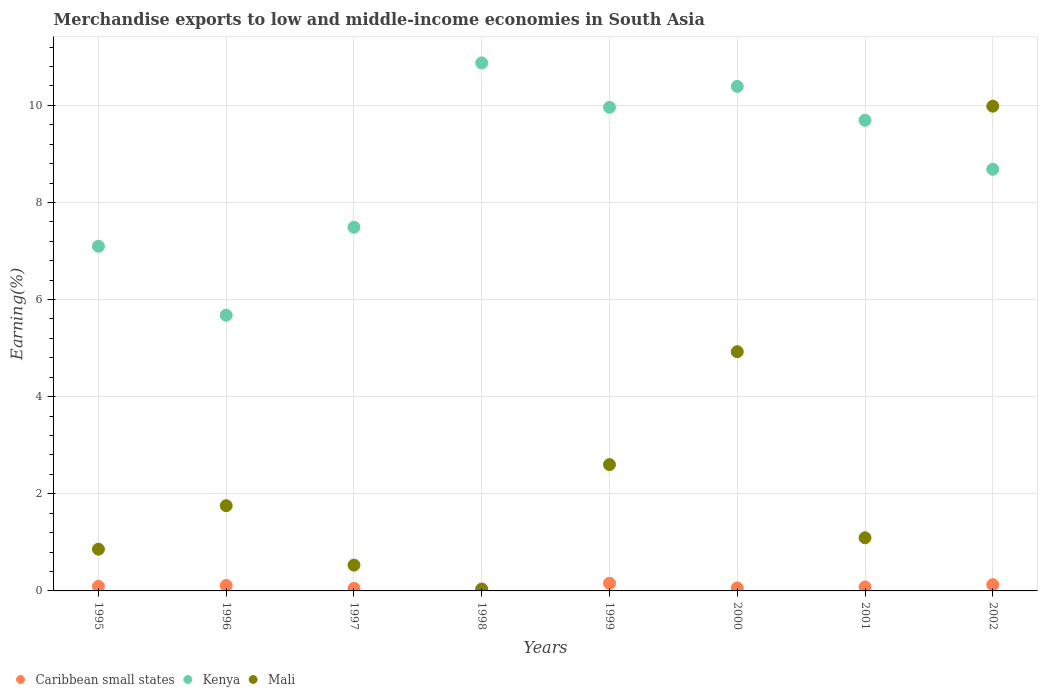How many different coloured dotlines are there?
Give a very brief answer. 3. What is the percentage of amount earned from merchandise exports in Mali in 2002?
Provide a succinct answer. 9.98. Across all years, what is the maximum percentage of amount earned from merchandise exports in Caribbean small states?
Your answer should be very brief. 0.16. Across all years, what is the minimum percentage of amount earned from merchandise exports in Kenya?
Your answer should be very brief. 5.68. In which year was the percentage of amount earned from merchandise exports in Mali minimum?
Provide a short and direct response. 1998. What is the total percentage of amount earned from merchandise exports in Mali in the graph?
Provide a succinct answer. 21.78. What is the difference between the percentage of amount earned from merchandise exports in Mali in 1996 and that in 1998?
Provide a short and direct response. 1.72. What is the difference between the percentage of amount earned from merchandise exports in Caribbean small states in 2002 and the percentage of amount earned from merchandise exports in Mali in 2001?
Offer a terse response. -0.97. What is the average percentage of amount earned from merchandise exports in Caribbean small states per year?
Ensure brevity in your answer.  0.09. In the year 1999, what is the difference between the percentage of amount earned from merchandise exports in Mali and percentage of amount earned from merchandise exports in Kenya?
Your answer should be compact. -7.36. In how many years, is the percentage of amount earned from merchandise exports in Kenya greater than 3.6 %?
Offer a terse response. 8. What is the ratio of the percentage of amount earned from merchandise exports in Mali in 2000 to that in 2001?
Your answer should be compact. 4.5. What is the difference between the highest and the second highest percentage of amount earned from merchandise exports in Kenya?
Your answer should be compact. 0.48. What is the difference between the highest and the lowest percentage of amount earned from merchandise exports in Kenya?
Ensure brevity in your answer.  5.2. How many dotlines are there?
Your answer should be compact. 3. How many years are there in the graph?
Make the answer very short. 8. Does the graph contain any zero values?
Offer a very short reply. No. Where does the legend appear in the graph?
Make the answer very short. Bottom left. How many legend labels are there?
Provide a succinct answer. 3. What is the title of the graph?
Offer a very short reply. Merchandise exports to low and middle-income economies in South Asia. What is the label or title of the Y-axis?
Provide a short and direct response. Earning(%). What is the Earning(%) in Caribbean small states in 1995?
Give a very brief answer. 0.09. What is the Earning(%) of Kenya in 1995?
Provide a short and direct response. 7.1. What is the Earning(%) of Mali in 1995?
Make the answer very short. 0.86. What is the Earning(%) of Caribbean small states in 1996?
Provide a short and direct response. 0.11. What is the Earning(%) in Kenya in 1996?
Make the answer very short. 5.68. What is the Earning(%) of Mali in 1996?
Your answer should be compact. 1.76. What is the Earning(%) in Caribbean small states in 1997?
Offer a very short reply. 0.05. What is the Earning(%) of Kenya in 1997?
Give a very brief answer. 7.49. What is the Earning(%) of Mali in 1997?
Provide a succinct answer. 0.53. What is the Earning(%) of Caribbean small states in 1998?
Your answer should be very brief. 0.04. What is the Earning(%) in Kenya in 1998?
Keep it short and to the point. 10.87. What is the Earning(%) in Mali in 1998?
Make the answer very short. 0.03. What is the Earning(%) of Caribbean small states in 1999?
Make the answer very short. 0.16. What is the Earning(%) in Kenya in 1999?
Your answer should be very brief. 9.96. What is the Earning(%) of Mali in 1999?
Provide a succinct answer. 2.6. What is the Earning(%) of Caribbean small states in 2000?
Offer a very short reply. 0.06. What is the Earning(%) in Kenya in 2000?
Your response must be concise. 10.39. What is the Earning(%) of Mali in 2000?
Provide a short and direct response. 4.93. What is the Earning(%) in Caribbean small states in 2001?
Keep it short and to the point. 0.08. What is the Earning(%) of Kenya in 2001?
Offer a very short reply. 9.69. What is the Earning(%) of Mali in 2001?
Your answer should be very brief. 1.09. What is the Earning(%) of Caribbean small states in 2002?
Make the answer very short. 0.13. What is the Earning(%) in Kenya in 2002?
Offer a terse response. 8.68. What is the Earning(%) of Mali in 2002?
Make the answer very short. 9.98. Across all years, what is the maximum Earning(%) in Caribbean small states?
Provide a short and direct response. 0.16. Across all years, what is the maximum Earning(%) in Kenya?
Ensure brevity in your answer.  10.87. Across all years, what is the maximum Earning(%) of Mali?
Provide a succinct answer. 9.98. Across all years, what is the minimum Earning(%) in Caribbean small states?
Your answer should be very brief. 0.04. Across all years, what is the minimum Earning(%) in Kenya?
Ensure brevity in your answer.  5.68. Across all years, what is the minimum Earning(%) of Mali?
Provide a short and direct response. 0.03. What is the total Earning(%) of Caribbean small states in the graph?
Provide a succinct answer. 0.73. What is the total Earning(%) of Kenya in the graph?
Ensure brevity in your answer.  69.86. What is the total Earning(%) in Mali in the graph?
Offer a terse response. 21.78. What is the difference between the Earning(%) of Caribbean small states in 1995 and that in 1996?
Offer a terse response. -0.02. What is the difference between the Earning(%) of Kenya in 1995 and that in 1996?
Make the answer very short. 1.42. What is the difference between the Earning(%) in Mali in 1995 and that in 1996?
Ensure brevity in your answer.  -0.9. What is the difference between the Earning(%) of Caribbean small states in 1995 and that in 1997?
Your answer should be compact. 0.04. What is the difference between the Earning(%) in Kenya in 1995 and that in 1997?
Offer a very short reply. -0.39. What is the difference between the Earning(%) of Mali in 1995 and that in 1997?
Keep it short and to the point. 0.33. What is the difference between the Earning(%) of Caribbean small states in 1995 and that in 1998?
Keep it short and to the point. 0.05. What is the difference between the Earning(%) of Kenya in 1995 and that in 1998?
Your answer should be compact. -3.78. What is the difference between the Earning(%) in Mali in 1995 and that in 1998?
Your response must be concise. 0.83. What is the difference between the Earning(%) in Caribbean small states in 1995 and that in 1999?
Offer a very short reply. -0.06. What is the difference between the Earning(%) of Kenya in 1995 and that in 1999?
Your answer should be very brief. -2.86. What is the difference between the Earning(%) in Mali in 1995 and that in 1999?
Your response must be concise. -1.74. What is the difference between the Earning(%) in Caribbean small states in 1995 and that in 2000?
Your answer should be compact. 0.03. What is the difference between the Earning(%) of Kenya in 1995 and that in 2000?
Provide a succinct answer. -3.29. What is the difference between the Earning(%) in Mali in 1995 and that in 2000?
Ensure brevity in your answer.  -4.07. What is the difference between the Earning(%) of Caribbean small states in 1995 and that in 2001?
Keep it short and to the point. 0.01. What is the difference between the Earning(%) of Kenya in 1995 and that in 2001?
Your answer should be compact. -2.59. What is the difference between the Earning(%) in Mali in 1995 and that in 2001?
Your answer should be very brief. -0.23. What is the difference between the Earning(%) of Caribbean small states in 1995 and that in 2002?
Offer a very short reply. -0.03. What is the difference between the Earning(%) of Kenya in 1995 and that in 2002?
Your answer should be very brief. -1.58. What is the difference between the Earning(%) in Mali in 1995 and that in 2002?
Make the answer very short. -9.12. What is the difference between the Earning(%) in Caribbean small states in 1996 and that in 1997?
Your response must be concise. 0.06. What is the difference between the Earning(%) of Kenya in 1996 and that in 1997?
Your response must be concise. -1.81. What is the difference between the Earning(%) of Mali in 1996 and that in 1997?
Your answer should be very brief. 1.22. What is the difference between the Earning(%) of Caribbean small states in 1996 and that in 1998?
Ensure brevity in your answer.  0.07. What is the difference between the Earning(%) in Kenya in 1996 and that in 1998?
Ensure brevity in your answer.  -5.2. What is the difference between the Earning(%) of Mali in 1996 and that in 1998?
Provide a succinct answer. 1.72. What is the difference between the Earning(%) in Caribbean small states in 1996 and that in 1999?
Offer a terse response. -0.05. What is the difference between the Earning(%) in Kenya in 1996 and that in 1999?
Give a very brief answer. -4.28. What is the difference between the Earning(%) of Mali in 1996 and that in 1999?
Give a very brief answer. -0.85. What is the difference between the Earning(%) of Caribbean small states in 1996 and that in 2000?
Your response must be concise. 0.05. What is the difference between the Earning(%) in Kenya in 1996 and that in 2000?
Make the answer very short. -4.71. What is the difference between the Earning(%) in Mali in 1996 and that in 2000?
Provide a short and direct response. -3.17. What is the difference between the Earning(%) in Kenya in 1996 and that in 2001?
Provide a short and direct response. -4.01. What is the difference between the Earning(%) in Mali in 1996 and that in 2001?
Your response must be concise. 0.66. What is the difference between the Earning(%) in Caribbean small states in 1996 and that in 2002?
Offer a terse response. -0.02. What is the difference between the Earning(%) of Kenya in 1996 and that in 2002?
Provide a short and direct response. -3. What is the difference between the Earning(%) of Mali in 1996 and that in 2002?
Keep it short and to the point. -8.23. What is the difference between the Earning(%) in Caribbean small states in 1997 and that in 1998?
Provide a short and direct response. 0.01. What is the difference between the Earning(%) in Kenya in 1997 and that in 1998?
Provide a succinct answer. -3.38. What is the difference between the Earning(%) in Mali in 1997 and that in 1998?
Your response must be concise. 0.5. What is the difference between the Earning(%) in Caribbean small states in 1997 and that in 1999?
Provide a succinct answer. -0.1. What is the difference between the Earning(%) in Kenya in 1997 and that in 1999?
Your response must be concise. -2.47. What is the difference between the Earning(%) in Mali in 1997 and that in 1999?
Provide a short and direct response. -2.07. What is the difference between the Earning(%) in Caribbean small states in 1997 and that in 2000?
Your answer should be compact. -0.01. What is the difference between the Earning(%) of Kenya in 1997 and that in 2000?
Your answer should be compact. -2.9. What is the difference between the Earning(%) of Mali in 1997 and that in 2000?
Your answer should be compact. -4.39. What is the difference between the Earning(%) of Caribbean small states in 1997 and that in 2001?
Offer a very short reply. -0.03. What is the difference between the Earning(%) of Kenya in 1997 and that in 2001?
Your answer should be very brief. -2.2. What is the difference between the Earning(%) of Mali in 1997 and that in 2001?
Your answer should be very brief. -0.56. What is the difference between the Earning(%) in Caribbean small states in 1997 and that in 2002?
Your answer should be compact. -0.08. What is the difference between the Earning(%) of Kenya in 1997 and that in 2002?
Your answer should be compact. -1.19. What is the difference between the Earning(%) in Mali in 1997 and that in 2002?
Keep it short and to the point. -9.45. What is the difference between the Earning(%) in Caribbean small states in 1998 and that in 1999?
Ensure brevity in your answer.  -0.12. What is the difference between the Earning(%) of Kenya in 1998 and that in 1999?
Provide a short and direct response. 0.91. What is the difference between the Earning(%) of Mali in 1998 and that in 1999?
Your response must be concise. -2.57. What is the difference between the Earning(%) in Caribbean small states in 1998 and that in 2000?
Ensure brevity in your answer.  -0.02. What is the difference between the Earning(%) of Kenya in 1998 and that in 2000?
Your answer should be compact. 0.48. What is the difference between the Earning(%) in Mali in 1998 and that in 2000?
Offer a terse response. -4.89. What is the difference between the Earning(%) of Caribbean small states in 1998 and that in 2001?
Provide a succinct answer. -0.04. What is the difference between the Earning(%) in Kenya in 1998 and that in 2001?
Give a very brief answer. 1.18. What is the difference between the Earning(%) of Mali in 1998 and that in 2001?
Provide a succinct answer. -1.06. What is the difference between the Earning(%) in Caribbean small states in 1998 and that in 2002?
Offer a very short reply. -0.09. What is the difference between the Earning(%) in Kenya in 1998 and that in 2002?
Your answer should be very brief. 2.19. What is the difference between the Earning(%) in Mali in 1998 and that in 2002?
Provide a succinct answer. -9.95. What is the difference between the Earning(%) in Caribbean small states in 1999 and that in 2000?
Give a very brief answer. 0.09. What is the difference between the Earning(%) in Kenya in 1999 and that in 2000?
Give a very brief answer. -0.43. What is the difference between the Earning(%) in Mali in 1999 and that in 2000?
Keep it short and to the point. -2.32. What is the difference between the Earning(%) of Caribbean small states in 1999 and that in 2001?
Provide a succinct answer. 0.08. What is the difference between the Earning(%) in Kenya in 1999 and that in 2001?
Offer a very short reply. 0.27. What is the difference between the Earning(%) of Mali in 1999 and that in 2001?
Offer a very short reply. 1.51. What is the difference between the Earning(%) of Caribbean small states in 1999 and that in 2002?
Provide a short and direct response. 0.03. What is the difference between the Earning(%) in Kenya in 1999 and that in 2002?
Your answer should be compact. 1.28. What is the difference between the Earning(%) in Mali in 1999 and that in 2002?
Offer a terse response. -7.38. What is the difference between the Earning(%) of Caribbean small states in 2000 and that in 2001?
Offer a terse response. -0.02. What is the difference between the Earning(%) of Kenya in 2000 and that in 2001?
Your answer should be compact. 0.7. What is the difference between the Earning(%) in Mali in 2000 and that in 2001?
Make the answer very short. 3.83. What is the difference between the Earning(%) of Caribbean small states in 2000 and that in 2002?
Your response must be concise. -0.07. What is the difference between the Earning(%) in Kenya in 2000 and that in 2002?
Keep it short and to the point. 1.71. What is the difference between the Earning(%) of Mali in 2000 and that in 2002?
Your answer should be compact. -5.06. What is the difference between the Earning(%) of Caribbean small states in 2001 and that in 2002?
Make the answer very short. -0.05. What is the difference between the Earning(%) in Kenya in 2001 and that in 2002?
Keep it short and to the point. 1.01. What is the difference between the Earning(%) in Mali in 2001 and that in 2002?
Your response must be concise. -8.89. What is the difference between the Earning(%) in Caribbean small states in 1995 and the Earning(%) in Kenya in 1996?
Your response must be concise. -5.58. What is the difference between the Earning(%) of Caribbean small states in 1995 and the Earning(%) of Mali in 1996?
Ensure brevity in your answer.  -1.66. What is the difference between the Earning(%) of Kenya in 1995 and the Earning(%) of Mali in 1996?
Your answer should be very brief. 5.34. What is the difference between the Earning(%) in Caribbean small states in 1995 and the Earning(%) in Kenya in 1997?
Provide a succinct answer. -7.39. What is the difference between the Earning(%) of Caribbean small states in 1995 and the Earning(%) of Mali in 1997?
Ensure brevity in your answer.  -0.44. What is the difference between the Earning(%) in Kenya in 1995 and the Earning(%) in Mali in 1997?
Your answer should be compact. 6.57. What is the difference between the Earning(%) of Caribbean small states in 1995 and the Earning(%) of Kenya in 1998?
Keep it short and to the point. -10.78. What is the difference between the Earning(%) of Caribbean small states in 1995 and the Earning(%) of Mali in 1998?
Your response must be concise. 0.06. What is the difference between the Earning(%) in Kenya in 1995 and the Earning(%) in Mali in 1998?
Make the answer very short. 7.07. What is the difference between the Earning(%) in Caribbean small states in 1995 and the Earning(%) in Kenya in 1999?
Provide a short and direct response. -9.86. What is the difference between the Earning(%) of Caribbean small states in 1995 and the Earning(%) of Mali in 1999?
Your answer should be very brief. -2.51. What is the difference between the Earning(%) of Kenya in 1995 and the Earning(%) of Mali in 1999?
Offer a terse response. 4.5. What is the difference between the Earning(%) in Caribbean small states in 1995 and the Earning(%) in Kenya in 2000?
Give a very brief answer. -10.3. What is the difference between the Earning(%) in Caribbean small states in 1995 and the Earning(%) in Mali in 2000?
Your answer should be compact. -4.83. What is the difference between the Earning(%) of Kenya in 1995 and the Earning(%) of Mali in 2000?
Make the answer very short. 2.17. What is the difference between the Earning(%) of Caribbean small states in 1995 and the Earning(%) of Kenya in 2001?
Your answer should be compact. -9.6. What is the difference between the Earning(%) in Caribbean small states in 1995 and the Earning(%) in Mali in 2001?
Provide a short and direct response. -1. What is the difference between the Earning(%) of Kenya in 1995 and the Earning(%) of Mali in 2001?
Provide a short and direct response. 6. What is the difference between the Earning(%) of Caribbean small states in 1995 and the Earning(%) of Kenya in 2002?
Keep it short and to the point. -8.59. What is the difference between the Earning(%) of Caribbean small states in 1995 and the Earning(%) of Mali in 2002?
Your response must be concise. -9.89. What is the difference between the Earning(%) of Kenya in 1995 and the Earning(%) of Mali in 2002?
Keep it short and to the point. -2.88. What is the difference between the Earning(%) of Caribbean small states in 1996 and the Earning(%) of Kenya in 1997?
Give a very brief answer. -7.38. What is the difference between the Earning(%) in Caribbean small states in 1996 and the Earning(%) in Mali in 1997?
Provide a succinct answer. -0.42. What is the difference between the Earning(%) in Kenya in 1996 and the Earning(%) in Mali in 1997?
Keep it short and to the point. 5.15. What is the difference between the Earning(%) of Caribbean small states in 1996 and the Earning(%) of Kenya in 1998?
Make the answer very short. -10.76. What is the difference between the Earning(%) of Caribbean small states in 1996 and the Earning(%) of Mali in 1998?
Give a very brief answer. 0.08. What is the difference between the Earning(%) of Kenya in 1996 and the Earning(%) of Mali in 1998?
Keep it short and to the point. 5.65. What is the difference between the Earning(%) of Caribbean small states in 1996 and the Earning(%) of Kenya in 1999?
Provide a succinct answer. -9.85. What is the difference between the Earning(%) in Caribbean small states in 1996 and the Earning(%) in Mali in 1999?
Provide a succinct answer. -2.49. What is the difference between the Earning(%) in Kenya in 1996 and the Earning(%) in Mali in 1999?
Your response must be concise. 3.08. What is the difference between the Earning(%) of Caribbean small states in 1996 and the Earning(%) of Kenya in 2000?
Offer a very short reply. -10.28. What is the difference between the Earning(%) of Caribbean small states in 1996 and the Earning(%) of Mali in 2000?
Offer a terse response. -4.81. What is the difference between the Earning(%) in Kenya in 1996 and the Earning(%) in Mali in 2000?
Your answer should be very brief. 0.75. What is the difference between the Earning(%) of Caribbean small states in 1996 and the Earning(%) of Kenya in 2001?
Offer a terse response. -9.58. What is the difference between the Earning(%) of Caribbean small states in 1996 and the Earning(%) of Mali in 2001?
Provide a succinct answer. -0.98. What is the difference between the Earning(%) in Kenya in 1996 and the Earning(%) in Mali in 2001?
Provide a short and direct response. 4.58. What is the difference between the Earning(%) of Caribbean small states in 1996 and the Earning(%) of Kenya in 2002?
Your response must be concise. -8.57. What is the difference between the Earning(%) of Caribbean small states in 1996 and the Earning(%) of Mali in 2002?
Make the answer very short. -9.87. What is the difference between the Earning(%) in Kenya in 1996 and the Earning(%) in Mali in 2002?
Offer a terse response. -4.3. What is the difference between the Earning(%) of Caribbean small states in 1997 and the Earning(%) of Kenya in 1998?
Your response must be concise. -10.82. What is the difference between the Earning(%) of Caribbean small states in 1997 and the Earning(%) of Mali in 1998?
Give a very brief answer. 0.02. What is the difference between the Earning(%) in Kenya in 1997 and the Earning(%) in Mali in 1998?
Your answer should be very brief. 7.46. What is the difference between the Earning(%) in Caribbean small states in 1997 and the Earning(%) in Kenya in 1999?
Offer a terse response. -9.91. What is the difference between the Earning(%) of Caribbean small states in 1997 and the Earning(%) of Mali in 1999?
Your answer should be very brief. -2.55. What is the difference between the Earning(%) of Kenya in 1997 and the Earning(%) of Mali in 1999?
Make the answer very short. 4.89. What is the difference between the Earning(%) in Caribbean small states in 1997 and the Earning(%) in Kenya in 2000?
Offer a very short reply. -10.34. What is the difference between the Earning(%) in Caribbean small states in 1997 and the Earning(%) in Mali in 2000?
Your answer should be compact. -4.87. What is the difference between the Earning(%) of Kenya in 1997 and the Earning(%) of Mali in 2000?
Ensure brevity in your answer.  2.56. What is the difference between the Earning(%) in Caribbean small states in 1997 and the Earning(%) in Kenya in 2001?
Your answer should be very brief. -9.64. What is the difference between the Earning(%) in Caribbean small states in 1997 and the Earning(%) in Mali in 2001?
Your answer should be very brief. -1.04. What is the difference between the Earning(%) in Kenya in 1997 and the Earning(%) in Mali in 2001?
Give a very brief answer. 6.4. What is the difference between the Earning(%) in Caribbean small states in 1997 and the Earning(%) in Kenya in 2002?
Make the answer very short. -8.63. What is the difference between the Earning(%) in Caribbean small states in 1997 and the Earning(%) in Mali in 2002?
Make the answer very short. -9.93. What is the difference between the Earning(%) of Kenya in 1997 and the Earning(%) of Mali in 2002?
Keep it short and to the point. -2.49. What is the difference between the Earning(%) of Caribbean small states in 1998 and the Earning(%) of Kenya in 1999?
Keep it short and to the point. -9.92. What is the difference between the Earning(%) in Caribbean small states in 1998 and the Earning(%) in Mali in 1999?
Your answer should be very brief. -2.56. What is the difference between the Earning(%) in Kenya in 1998 and the Earning(%) in Mali in 1999?
Provide a short and direct response. 8.27. What is the difference between the Earning(%) in Caribbean small states in 1998 and the Earning(%) in Kenya in 2000?
Make the answer very short. -10.35. What is the difference between the Earning(%) of Caribbean small states in 1998 and the Earning(%) of Mali in 2000?
Offer a very short reply. -4.88. What is the difference between the Earning(%) of Kenya in 1998 and the Earning(%) of Mali in 2000?
Offer a terse response. 5.95. What is the difference between the Earning(%) in Caribbean small states in 1998 and the Earning(%) in Kenya in 2001?
Offer a terse response. -9.65. What is the difference between the Earning(%) in Caribbean small states in 1998 and the Earning(%) in Mali in 2001?
Offer a very short reply. -1.05. What is the difference between the Earning(%) of Kenya in 1998 and the Earning(%) of Mali in 2001?
Offer a terse response. 9.78. What is the difference between the Earning(%) in Caribbean small states in 1998 and the Earning(%) in Kenya in 2002?
Provide a succinct answer. -8.64. What is the difference between the Earning(%) of Caribbean small states in 1998 and the Earning(%) of Mali in 2002?
Your response must be concise. -9.94. What is the difference between the Earning(%) of Kenya in 1998 and the Earning(%) of Mali in 2002?
Offer a terse response. 0.89. What is the difference between the Earning(%) of Caribbean small states in 1999 and the Earning(%) of Kenya in 2000?
Provide a succinct answer. -10.23. What is the difference between the Earning(%) in Caribbean small states in 1999 and the Earning(%) in Mali in 2000?
Keep it short and to the point. -4.77. What is the difference between the Earning(%) in Kenya in 1999 and the Earning(%) in Mali in 2000?
Offer a terse response. 5.03. What is the difference between the Earning(%) of Caribbean small states in 1999 and the Earning(%) of Kenya in 2001?
Provide a succinct answer. -9.53. What is the difference between the Earning(%) in Caribbean small states in 1999 and the Earning(%) in Mali in 2001?
Your answer should be compact. -0.94. What is the difference between the Earning(%) of Kenya in 1999 and the Earning(%) of Mali in 2001?
Your answer should be compact. 8.86. What is the difference between the Earning(%) in Caribbean small states in 1999 and the Earning(%) in Kenya in 2002?
Make the answer very short. -8.53. What is the difference between the Earning(%) of Caribbean small states in 1999 and the Earning(%) of Mali in 2002?
Your response must be concise. -9.82. What is the difference between the Earning(%) in Kenya in 1999 and the Earning(%) in Mali in 2002?
Offer a terse response. -0.02. What is the difference between the Earning(%) in Caribbean small states in 2000 and the Earning(%) in Kenya in 2001?
Keep it short and to the point. -9.63. What is the difference between the Earning(%) of Caribbean small states in 2000 and the Earning(%) of Mali in 2001?
Offer a terse response. -1.03. What is the difference between the Earning(%) in Kenya in 2000 and the Earning(%) in Mali in 2001?
Ensure brevity in your answer.  9.3. What is the difference between the Earning(%) of Caribbean small states in 2000 and the Earning(%) of Kenya in 2002?
Your response must be concise. -8.62. What is the difference between the Earning(%) in Caribbean small states in 2000 and the Earning(%) in Mali in 2002?
Your response must be concise. -9.92. What is the difference between the Earning(%) of Kenya in 2000 and the Earning(%) of Mali in 2002?
Offer a very short reply. 0.41. What is the difference between the Earning(%) of Caribbean small states in 2001 and the Earning(%) of Kenya in 2002?
Give a very brief answer. -8.6. What is the difference between the Earning(%) in Caribbean small states in 2001 and the Earning(%) in Mali in 2002?
Offer a terse response. -9.9. What is the difference between the Earning(%) in Kenya in 2001 and the Earning(%) in Mali in 2002?
Ensure brevity in your answer.  -0.29. What is the average Earning(%) of Caribbean small states per year?
Your answer should be compact. 0.09. What is the average Earning(%) in Kenya per year?
Keep it short and to the point. 8.73. What is the average Earning(%) in Mali per year?
Offer a terse response. 2.72. In the year 1995, what is the difference between the Earning(%) in Caribbean small states and Earning(%) in Kenya?
Your answer should be very brief. -7. In the year 1995, what is the difference between the Earning(%) in Caribbean small states and Earning(%) in Mali?
Provide a short and direct response. -0.77. In the year 1995, what is the difference between the Earning(%) in Kenya and Earning(%) in Mali?
Make the answer very short. 6.24. In the year 1996, what is the difference between the Earning(%) of Caribbean small states and Earning(%) of Kenya?
Keep it short and to the point. -5.57. In the year 1996, what is the difference between the Earning(%) of Caribbean small states and Earning(%) of Mali?
Ensure brevity in your answer.  -1.64. In the year 1996, what is the difference between the Earning(%) in Kenya and Earning(%) in Mali?
Offer a terse response. 3.92. In the year 1997, what is the difference between the Earning(%) in Caribbean small states and Earning(%) in Kenya?
Ensure brevity in your answer.  -7.44. In the year 1997, what is the difference between the Earning(%) in Caribbean small states and Earning(%) in Mali?
Your response must be concise. -0.48. In the year 1997, what is the difference between the Earning(%) of Kenya and Earning(%) of Mali?
Ensure brevity in your answer.  6.96. In the year 1998, what is the difference between the Earning(%) of Caribbean small states and Earning(%) of Kenya?
Provide a succinct answer. -10.83. In the year 1998, what is the difference between the Earning(%) in Caribbean small states and Earning(%) in Mali?
Make the answer very short. 0.01. In the year 1998, what is the difference between the Earning(%) of Kenya and Earning(%) of Mali?
Give a very brief answer. 10.84. In the year 1999, what is the difference between the Earning(%) of Caribbean small states and Earning(%) of Kenya?
Provide a succinct answer. -9.8. In the year 1999, what is the difference between the Earning(%) of Caribbean small states and Earning(%) of Mali?
Offer a terse response. -2.44. In the year 1999, what is the difference between the Earning(%) of Kenya and Earning(%) of Mali?
Provide a short and direct response. 7.36. In the year 2000, what is the difference between the Earning(%) in Caribbean small states and Earning(%) in Kenya?
Ensure brevity in your answer.  -10.33. In the year 2000, what is the difference between the Earning(%) in Caribbean small states and Earning(%) in Mali?
Your response must be concise. -4.86. In the year 2000, what is the difference between the Earning(%) in Kenya and Earning(%) in Mali?
Keep it short and to the point. 5.46. In the year 2001, what is the difference between the Earning(%) of Caribbean small states and Earning(%) of Kenya?
Your answer should be very brief. -9.61. In the year 2001, what is the difference between the Earning(%) in Caribbean small states and Earning(%) in Mali?
Your answer should be compact. -1.01. In the year 2001, what is the difference between the Earning(%) of Kenya and Earning(%) of Mali?
Provide a succinct answer. 8.6. In the year 2002, what is the difference between the Earning(%) of Caribbean small states and Earning(%) of Kenya?
Your answer should be compact. -8.55. In the year 2002, what is the difference between the Earning(%) in Caribbean small states and Earning(%) in Mali?
Ensure brevity in your answer.  -9.85. In the year 2002, what is the difference between the Earning(%) in Kenya and Earning(%) in Mali?
Offer a terse response. -1.3. What is the ratio of the Earning(%) in Caribbean small states in 1995 to that in 1996?
Offer a very short reply. 0.85. What is the ratio of the Earning(%) of Kenya in 1995 to that in 1996?
Provide a short and direct response. 1.25. What is the ratio of the Earning(%) of Mali in 1995 to that in 1996?
Your answer should be compact. 0.49. What is the ratio of the Earning(%) in Caribbean small states in 1995 to that in 1997?
Your response must be concise. 1.77. What is the ratio of the Earning(%) of Kenya in 1995 to that in 1997?
Your response must be concise. 0.95. What is the ratio of the Earning(%) of Mali in 1995 to that in 1997?
Your answer should be compact. 1.62. What is the ratio of the Earning(%) of Caribbean small states in 1995 to that in 1998?
Your answer should be compact. 2.26. What is the ratio of the Earning(%) in Kenya in 1995 to that in 1998?
Your answer should be very brief. 0.65. What is the ratio of the Earning(%) of Mali in 1995 to that in 1998?
Make the answer very short. 27.83. What is the ratio of the Earning(%) of Caribbean small states in 1995 to that in 1999?
Give a very brief answer. 0.6. What is the ratio of the Earning(%) of Kenya in 1995 to that in 1999?
Offer a terse response. 0.71. What is the ratio of the Earning(%) in Mali in 1995 to that in 1999?
Your response must be concise. 0.33. What is the ratio of the Earning(%) of Caribbean small states in 1995 to that in 2000?
Keep it short and to the point. 1.5. What is the ratio of the Earning(%) of Kenya in 1995 to that in 2000?
Your answer should be compact. 0.68. What is the ratio of the Earning(%) of Mali in 1995 to that in 2000?
Your answer should be very brief. 0.17. What is the ratio of the Earning(%) in Caribbean small states in 1995 to that in 2001?
Your response must be concise. 1.16. What is the ratio of the Earning(%) of Kenya in 1995 to that in 2001?
Ensure brevity in your answer.  0.73. What is the ratio of the Earning(%) of Mali in 1995 to that in 2001?
Give a very brief answer. 0.79. What is the ratio of the Earning(%) of Caribbean small states in 1995 to that in 2002?
Offer a very short reply. 0.73. What is the ratio of the Earning(%) of Kenya in 1995 to that in 2002?
Offer a very short reply. 0.82. What is the ratio of the Earning(%) in Mali in 1995 to that in 2002?
Give a very brief answer. 0.09. What is the ratio of the Earning(%) of Caribbean small states in 1996 to that in 1997?
Keep it short and to the point. 2.08. What is the ratio of the Earning(%) in Kenya in 1996 to that in 1997?
Your answer should be very brief. 0.76. What is the ratio of the Earning(%) in Mali in 1996 to that in 1997?
Provide a succinct answer. 3.3. What is the ratio of the Earning(%) in Caribbean small states in 1996 to that in 1998?
Provide a short and direct response. 2.66. What is the ratio of the Earning(%) of Kenya in 1996 to that in 1998?
Your answer should be very brief. 0.52. What is the ratio of the Earning(%) of Mali in 1996 to that in 1998?
Provide a succinct answer. 56.83. What is the ratio of the Earning(%) in Caribbean small states in 1996 to that in 1999?
Keep it short and to the point. 0.71. What is the ratio of the Earning(%) in Kenya in 1996 to that in 1999?
Provide a succinct answer. 0.57. What is the ratio of the Earning(%) of Mali in 1996 to that in 1999?
Your answer should be compact. 0.67. What is the ratio of the Earning(%) of Caribbean small states in 1996 to that in 2000?
Your answer should be compact. 1.77. What is the ratio of the Earning(%) of Kenya in 1996 to that in 2000?
Offer a very short reply. 0.55. What is the ratio of the Earning(%) of Mali in 1996 to that in 2000?
Provide a succinct answer. 0.36. What is the ratio of the Earning(%) in Caribbean small states in 1996 to that in 2001?
Offer a very short reply. 1.37. What is the ratio of the Earning(%) in Kenya in 1996 to that in 2001?
Make the answer very short. 0.59. What is the ratio of the Earning(%) in Mali in 1996 to that in 2001?
Give a very brief answer. 1.6. What is the ratio of the Earning(%) of Caribbean small states in 1996 to that in 2002?
Your response must be concise. 0.86. What is the ratio of the Earning(%) of Kenya in 1996 to that in 2002?
Your answer should be very brief. 0.65. What is the ratio of the Earning(%) in Mali in 1996 to that in 2002?
Make the answer very short. 0.18. What is the ratio of the Earning(%) in Caribbean small states in 1997 to that in 1998?
Provide a succinct answer. 1.28. What is the ratio of the Earning(%) in Kenya in 1997 to that in 1998?
Offer a very short reply. 0.69. What is the ratio of the Earning(%) in Mali in 1997 to that in 1998?
Ensure brevity in your answer.  17.22. What is the ratio of the Earning(%) of Caribbean small states in 1997 to that in 1999?
Your answer should be compact. 0.34. What is the ratio of the Earning(%) of Kenya in 1997 to that in 1999?
Your answer should be very brief. 0.75. What is the ratio of the Earning(%) in Mali in 1997 to that in 1999?
Your answer should be very brief. 0.2. What is the ratio of the Earning(%) in Caribbean small states in 1997 to that in 2000?
Keep it short and to the point. 0.85. What is the ratio of the Earning(%) in Kenya in 1997 to that in 2000?
Your answer should be very brief. 0.72. What is the ratio of the Earning(%) in Mali in 1997 to that in 2000?
Your response must be concise. 0.11. What is the ratio of the Earning(%) in Caribbean small states in 1997 to that in 2001?
Offer a terse response. 0.66. What is the ratio of the Earning(%) of Kenya in 1997 to that in 2001?
Your answer should be compact. 0.77. What is the ratio of the Earning(%) of Mali in 1997 to that in 2001?
Your answer should be compact. 0.49. What is the ratio of the Earning(%) of Caribbean small states in 1997 to that in 2002?
Make the answer very short. 0.42. What is the ratio of the Earning(%) in Kenya in 1997 to that in 2002?
Keep it short and to the point. 0.86. What is the ratio of the Earning(%) in Mali in 1997 to that in 2002?
Give a very brief answer. 0.05. What is the ratio of the Earning(%) in Caribbean small states in 1998 to that in 1999?
Keep it short and to the point. 0.27. What is the ratio of the Earning(%) of Kenya in 1998 to that in 1999?
Your response must be concise. 1.09. What is the ratio of the Earning(%) in Mali in 1998 to that in 1999?
Give a very brief answer. 0.01. What is the ratio of the Earning(%) of Caribbean small states in 1998 to that in 2000?
Keep it short and to the point. 0.67. What is the ratio of the Earning(%) of Kenya in 1998 to that in 2000?
Offer a terse response. 1.05. What is the ratio of the Earning(%) in Mali in 1998 to that in 2000?
Offer a terse response. 0.01. What is the ratio of the Earning(%) of Caribbean small states in 1998 to that in 2001?
Ensure brevity in your answer.  0.51. What is the ratio of the Earning(%) in Kenya in 1998 to that in 2001?
Keep it short and to the point. 1.12. What is the ratio of the Earning(%) of Mali in 1998 to that in 2001?
Ensure brevity in your answer.  0.03. What is the ratio of the Earning(%) of Caribbean small states in 1998 to that in 2002?
Make the answer very short. 0.32. What is the ratio of the Earning(%) in Kenya in 1998 to that in 2002?
Your answer should be compact. 1.25. What is the ratio of the Earning(%) in Mali in 1998 to that in 2002?
Keep it short and to the point. 0. What is the ratio of the Earning(%) of Caribbean small states in 1999 to that in 2000?
Your answer should be very brief. 2.51. What is the ratio of the Earning(%) in Kenya in 1999 to that in 2000?
Give a very brief answer. 0.96. What is the ratio of the Earning(%) in Mali in 1999 to that in 2000?
Offer a very short reply. 0.53. What is the ratio of the Earning(%) of Caribbean small states in 1999 to that in 2001?
Your answer should be very brief. 1.94. What is the ratio of the Earning(%) in Kenya in 1999 to that in 2001?
Make the answer very short. 1.03. What is the ratio of the Earning(%) in Mali in 1999 to that in 2001?
Your response must be concise. 2.38. What is the ratio of the Earning(%) in Caribbean small states in 1999 to that in 2002?
Make the answer very short. 1.22. What is the ratio of the Earning(%) in Kenya in 1999 to that in 2002?
Your answer should be compact. 1.15. What is the ratio of the Earning(%) in Mali in 1999 to that in 2002?
Provide a short and direct response. 0.26. What is the ratio of the Earning(%) in Caribbean small states in 2000 to that in 2001?
Keep it short and to the point. 0.77. What is the ratio of the Earning(%) in Kenya in 2000 to that in 2001?
Offer a very short reply. 1.07. What is the ratio of the Earning(%) in Mali in 2000 to that in 2001?
Your answer should be very brief. 4.5. What is the ratio of the Earning(%) of Caribbean small states in 2000 to that in 2002?
Make the answer very short. 0.49. What is the ratio of the Earning(%) in Kenya in 2000 to that in 2002?
Your response must be concise. 1.2. What is the ratio of the Earning(%) of Mali in 2000 to that in 2002?
Provide a succinct answer. 0.49. What is the ratio of the Earning(%) of Caribbean small states in 2001 to that in 2002?
Make the answer very short. 0.63. What is the ratio of the Earning(%) in Kenya in 2001 to that in 2002?
Make the answer very short. 1.12. What is the ratio of the Earning(%) in Mali in 2001 to that in 2002?
Provide a short and direct response. 0.11. What is the difference between the highest and the second highest Earning(%) of Caribbean small states?
Your response must be concise. 0.03. What is the difference between the highest and the second highest Earning(%) in Kenya?
Provide a succinct answer. 0.48. What is the difference between the highest and the second highest Earning(%) of Mali?
Keep it short and to the point. 5.06. What is the difference between the highest and the lowest Earning(%) in Caribbean small states?
Provide a short and direct response. 0.12. What is the difference between the highest and the lowest Earning(%) in Kenya?
Your response must be concise. 5.2. What is the difference between the highest and the lowest Earning(%) in Mali?
Make the answer very short. 9.95. 